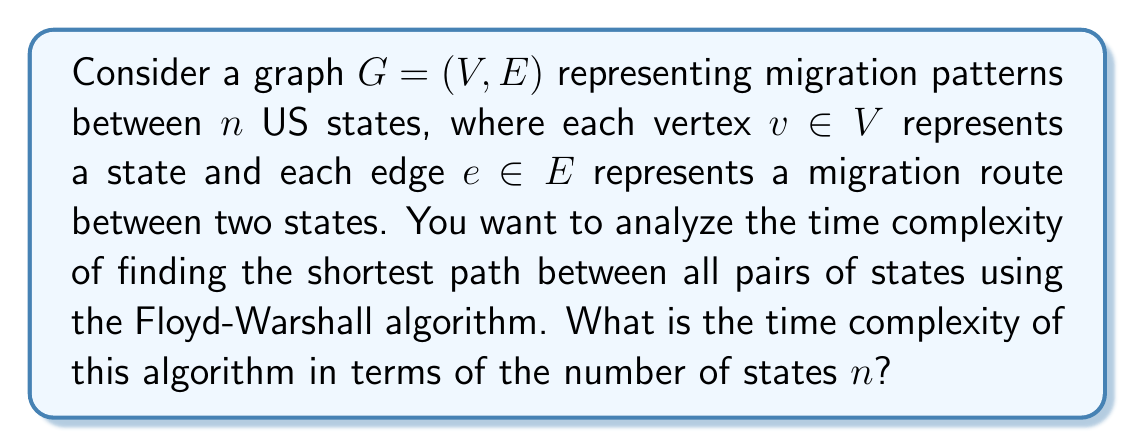Provide a solution to this math problem. To solve this problem, let's break down the Floyd-Warshall algorithm and analyze its time complexity:

1. The Floyd-Warshall algorithm is used to find the shortest paths between all pairs of vertices in a weighted graph.

2. It works by iteratively improving an estimate on the shortest path between two vertices, until the estimate is optimal.

3. The algorithm structure consists of three nested loops:

   ```
   for k = 1 to n
       for i = 1 to n
           for j = 1 to n
               if dist[i][j] > dist[i][k] + dist[k][j]
                   dist[i][j] = dist[i][k] + dist[k][j]
   ```

4. Each of these loops iterates $n$ times, where $n$ is the number of vertices (states in this case).

5. The innermost operation (comparison and potential update) is performed in constant time, $O(1)$.

6. Therefore, the total number of operations is:

   $$n \cdot n \cdot n \cdot O(1) = O(n^3)$$

7. This cubic time complexity $O(n^3)$ is characteristic of the Floyd-Warshall algorithm.

8. In the context of migration patterns, this means that as the number of states increases, the time to compute all shortest paths between them grows cubically.

9. While this may seem high, it's important to note that this algorithm computes shortest paths between all pairs of states in a single execution, which can be valuable for comprehensive migration pattern analysis.
Answer: The time complexity of the Floyd-Warshall algorithm for finding the shortest paths between all pairs of states in the migration pattern graph is $O(n^3)$, where $n$ is the number of states. 